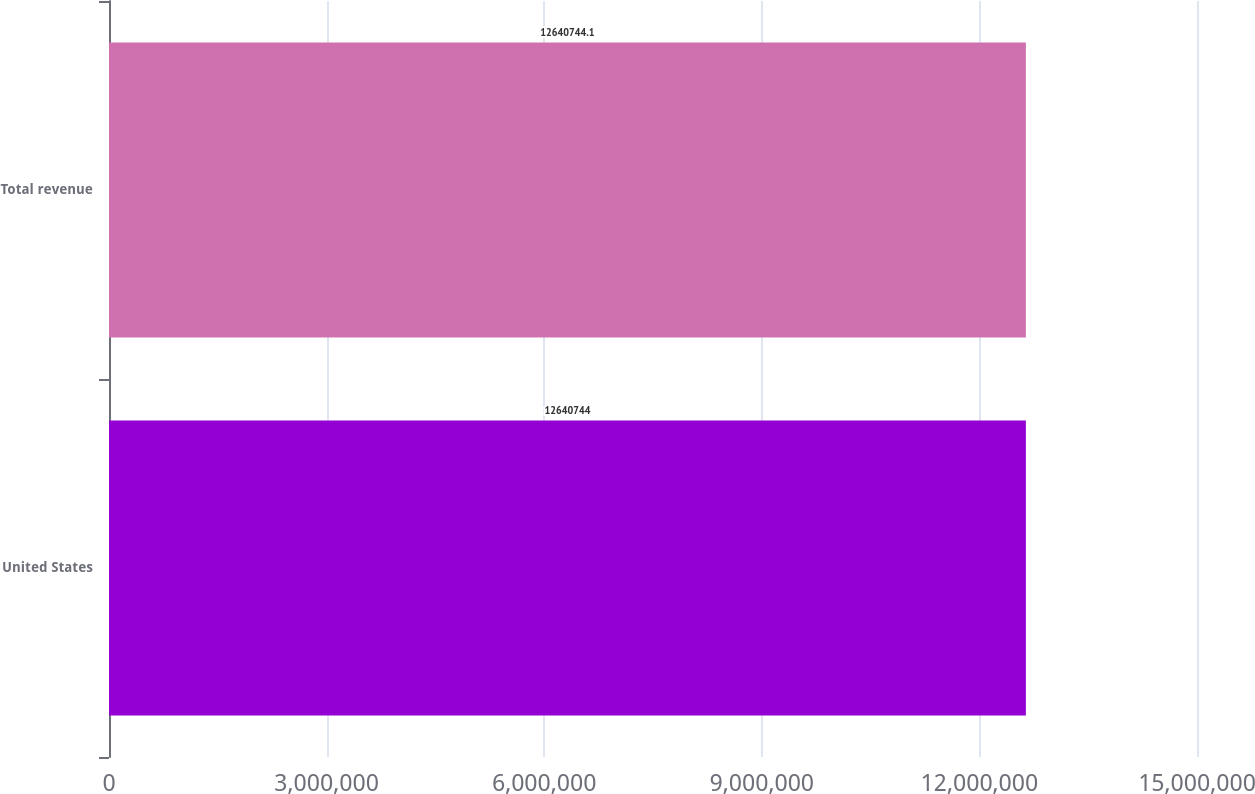Convert chart. <chart><loc_0><loc_0><loc_500><loc_500><bar_chart><fcel>United States<fcel>Total revenue<nl><fcel>1.26407e+07<fcel>1.26407e+07<nl></chart> 